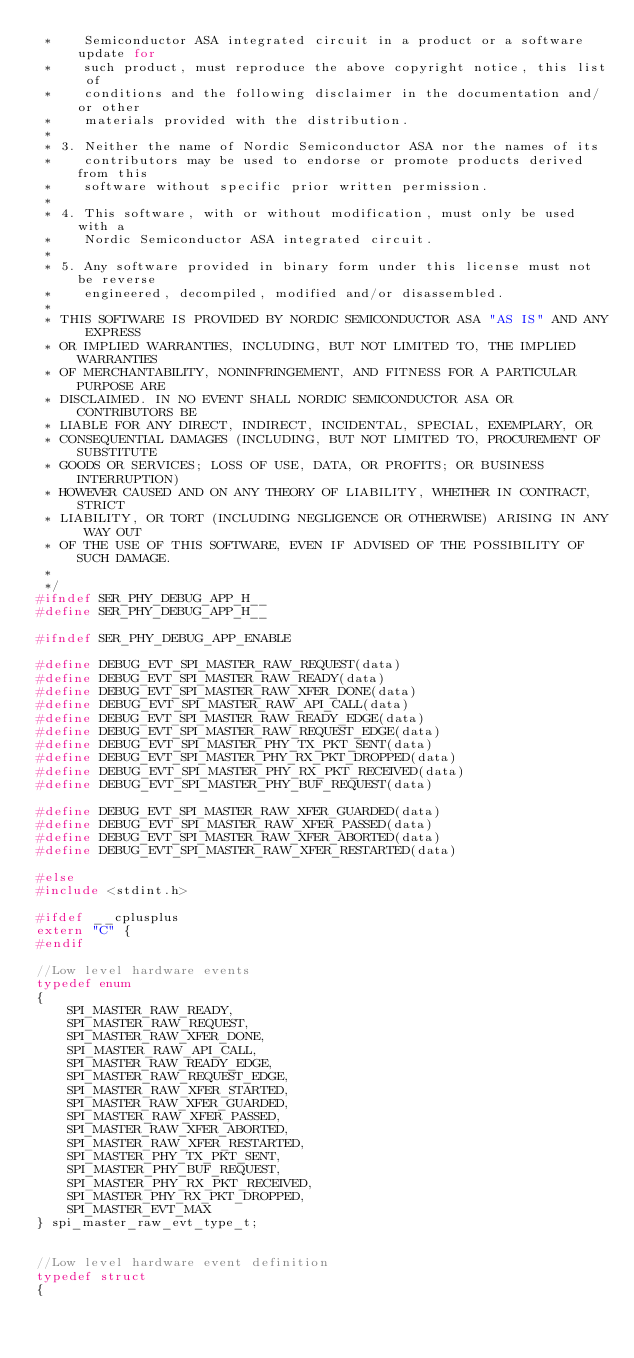Convert code to text. <code><loc_0><loc_0><loc_500><loc_500><_C_> *    Semiconductor ASA integrated circuit in a product or a software update for
 *    such product, must reproduce the above copyright notice, this list of
 *    conditions and the following disclaimer in the documentation and/or other
 *    materials provided with the distribution.
 * 
 * 3. Neither the name of Nordic Semiconductor ASA nor the names of its
 *    contributors may be used to endorse or promote products derived from this
 *    software without specific prior written permission.
 * 
 * 4. This software, with or without modification, must only be used with a
 *    Nordic Semiconductor ASA integrated circuit.
 * 
 * 5. Any software provided in binary form under this license must not be reverse
 *    engineered, decompiled, modified and/or disassembled.
 * 
 * THIS SOFTWARE IS PROVIDED BY NORDIC SEMICONDUCTOR ASA "AS IS" AND ANY EXPRESS
 * OR IMPLIED WARRANTIES, INCLUDING, BUT NOT LIMITED TO, THE IMPLIED WARRANTIES
 * OF MERCHANTABILITY, NONINFRINGEMENT, AND FITNESS FOR A PARTICULAR PURPOSE ARE
 * DISCLAIMED. IN NO EVENT SHALL NORDIC SEMICONDUCTOR ASA OR CONTRIBUTORS BE
 * LIABLE FOR ANY DIRECT, INDIRECT, INCIDENTAL, SPECIAL, EXEMPLARY, OR
 * CONSEQUENTIAL DAMAGES (INCLUDING, BUT NOT LIMITED TO, PROCUREMENT OF SUBSTITUTE
 * GOODS OR SERVICES; LOSS OF USE, DATA, OR PROFITS; OR BUSINESS INTERRUPTION)
 * HOWEVER CAUSED AND ON ANY THEORY OF LIABILITY, WHETHER IN CONTRACT, STRICT
 * LIABILITY, OR TORT (INCLUDING NEGLIGENCE OR OTHERWISE) ARISING IN ANY WAY OUT
 * OF THE USE OF THIS SOFTWARE, EVEN IF ADVISED OF THE POSSIBILITY OF SUCH DAMAGE.
 * 
 */
#ifndef SER_PHY_DEBUG_APP_H__
#define SER_PHY_DEBUG_APP_H__

#ifndef SER_PHY_DEBUG_APP_ENABLE

#define DEBUG_EVT_SPI_MASTER_RAW_REQUEST(data)
#define DEBUG_EVT_SPI_MASTER_RAW_READY(data)
#define DEBUG_EVT_SPI_MASTER_RAW_XFER_DONE(data)
#define DEBUG_EVT_SPI_MASTER_RAW_API_CALL(data)
#define DEBUG_EVT_SPI_MASTER_RAW_READY_EDGE(data)
#define DEBUG_EVT_SPI_MASTER_RAW_REQUEST_EDGE(data)
#define DEBUG_EVT_SPI_MASTER_PHY_TX_PKT_SENT(data)
#define DEBUG_EVT_SPI_MASTER_PHY_RX_PKT_DROPPED(data)
#define DEBUG_EVT_SPI_MASTER_PHY_RX_PKT_RECEIVED(data)
#define DEBUG_EVT_SPI_MASTER_PHY_BUF_REQUEST(data)

#define DEBUG_EVT_SPI_MASTER_RAW_XFER_GUARDED(data)
#define DEBUG_EVT_SPI_MASTER_RAW_XFER_PASSED(data)
#define DEBUG_EVT_SPI_MASTER_RAW_XFER_ABORTED(data)
#define DEBUG_EVT_SPI_MASTER_RAW_XFER_RESTARTED(data)

#else
#include <stdint.h>

#ifdef __cplusplus
extern "C" {
#endif

//Low level hardware events
typedef enum
{
    SPI_MASTER_RAW_READY,
    SPI_MASTER_RAW_REQUEST,
    SPI_MASTER_RAW_XFER_DONE,
    SPI_MASTER_RAW_API_CALL,
    SPI_MASTER_RAW_READY_EDGE,
    SPI_MASTER_RAW_REQUEST_EDGE,
    SPI_MASTER_RAW_XFER_STARTED,
    SPI_MASTER_RAW_XFER_GUARDED,
    SPI_MASTER_RAW_XFER_PASSED,
    SPI_MASTER_RAW_XFER_ABORTED,
    SPI_MASTER_RAW_XFER_RESTARTED,
    SPI_MASTER_PHY_TX_PKT_SENT,
    SPI_MASTER_PHY_BUF_REQUEST,
    SPI_MASTER_PHY_RX_PKT_RECEIVED,
    SPI_MASTER_PHY_RX_PKT_DROPPED,
    SPI_MASTER_EVT_MAX
} spi_master_raw_evt_type_t;


//Low level hardware event definition
typedef struct
{</code> 